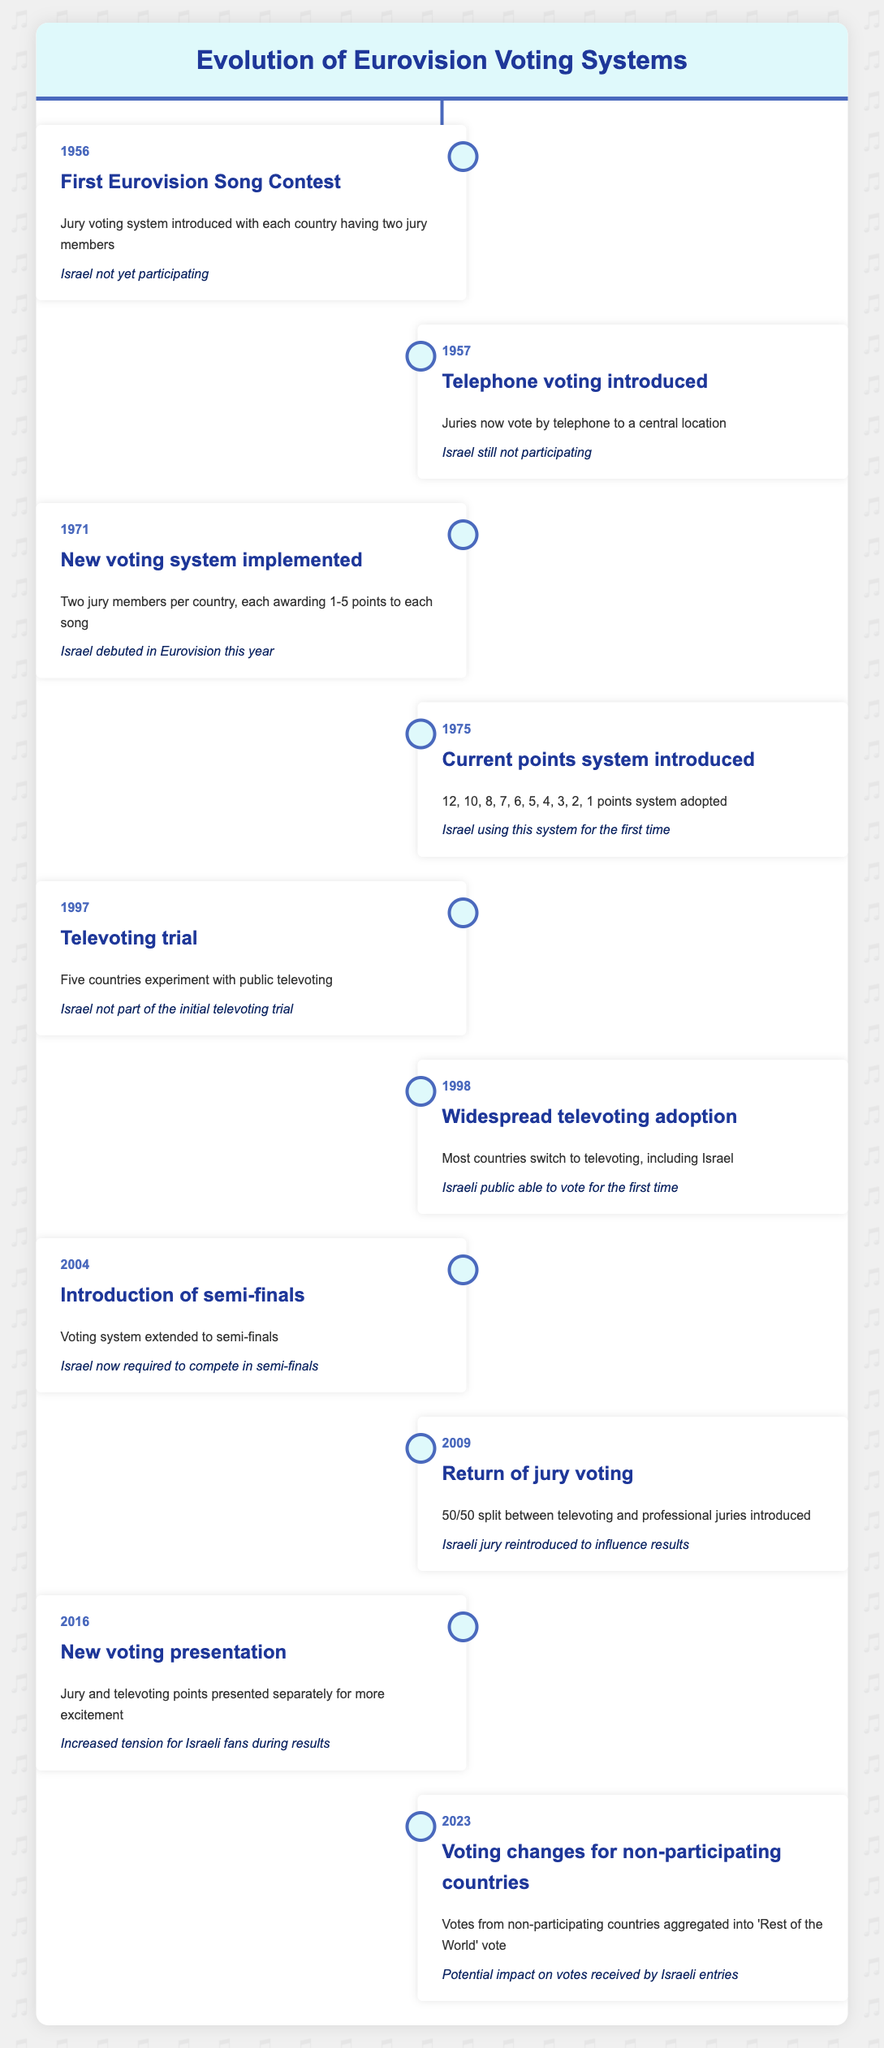What year did Israel debut in the Eurovision Song Contest? The table indicates that Israel debuted in Eurovision in 1971, which is mentioned in the entry for that year.
Answer: 1971 How many years did it take from the first Eurovision Song Contest to the introduction of the current points system? The first Eurovision took place in 1956, and the current points system was introduced in 1975. The difference between these years is 1975 - 1956 = 19 years.
Answer: 19 years Did Israel participate in the initial televoting trial in 1997? According to the table, Israel was not part of the initial televoting trial, which is clearly stated in the 1997 entry.
Answer: No What voting system was introduced in 2009? The table notes that in 2009, a return to jury voting occurred, with a 50/50 split between televoting and professional juries.
Answer: 50/50 split between televoting and professional juries How many total changes in voting systems are documented from 1956 to 2023? By counting all the individual events listed from 1956 to 2023 in the table, there are 10 distinct events or changes in voting systems, indicating that these were the major updates historically.
Answer: 10 changes In what year did Israel start using the points system that is still in use today? From the data, it is evident that Israel began using the current points system in 1975, which was the first time it was adopted.
Answer: 1975 What voting system change occurred in 2023? The vote from non-participating countries was aggregated into a 'Rest of the World' vote, according to the 2023 entry in the table.
Answer: Aggregation of 'Rest of the World' votes Compare the voting systems of 1975 and 2009. How are they different? The voting system in 1975 was the adoption of the 12, 10, 8, 7, 6, 5, 4, 3, 2, 1 points system, while in 2009, a new system was introduced that included a return of jury voting with a 50/50 split between televotes and jury votes. Therefore, the main difference lies in the role of jury voting.
Answer: 1975: points system; 2009: 50/50 split between jury and televotes Was there a year when there was a complete focus on jury voting without televoting? The table shows that the jury voting was fully returned in 2009, indicating a balance with televoting rather than a complete focus. Televoting started being widely adopted in 1998. Therefore, there was no year of complete jury voting without some form of televoting present.
Answer: No 